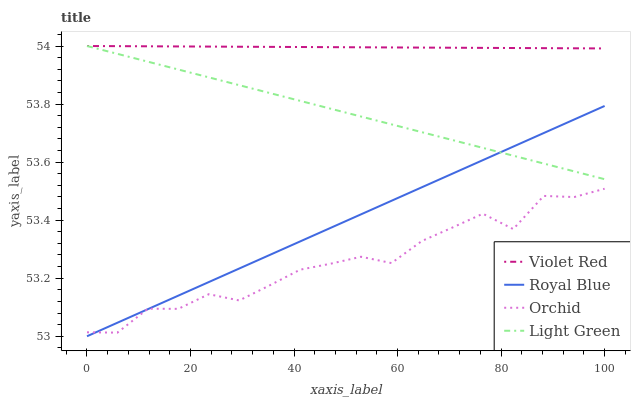Does Orchid have the minimum area under the curve?
Answer yes or no. Yes. Does Violet Red have the maximum area under the curve?
Answer yes or no. Yes. Does Light Green have the minimum area under the curve?
Answer yes or no. No. Does Light Green have the maximum area under the curve?
Answer yes or no. No. Is Light Green the smoothest?
Answer yes or no. Yes. Is Orchid the roughest?
Answer yes or no. Yes. Is Violet Red the smoothest?
Answer yes or no. No. Is Violet Red the roughest?
Answer yes or no. No. Does Light Green have the lowest value?
Answer yes or no. No. Does Orchid have the highest value?
Answer yes or no. No. Is Royal Blue less than Violet Red?
Answer yes or no. Yes. Is Violet Red greater than Orchid?
Answer yes or no. Yes. Does Royal Blue intersect Violet Red?
Answer yes or no. No. 